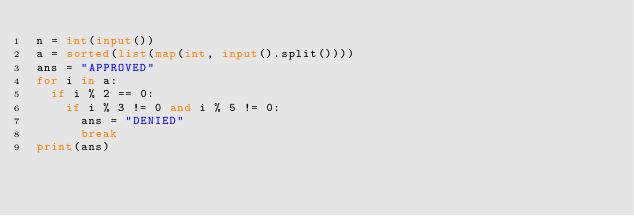<code> <loc_0><loc_0><loc_500><loc_500><_Python_>n = int(input())
a = sorted(list(map(int, input().split())))
ans = "APPROVED"
for i in a:
  if i % 2 == 0:
    if i % 3 != 0 and i % 5 != 0:
      ans = "DENIED"
      break
print(ans)   
 </code> 